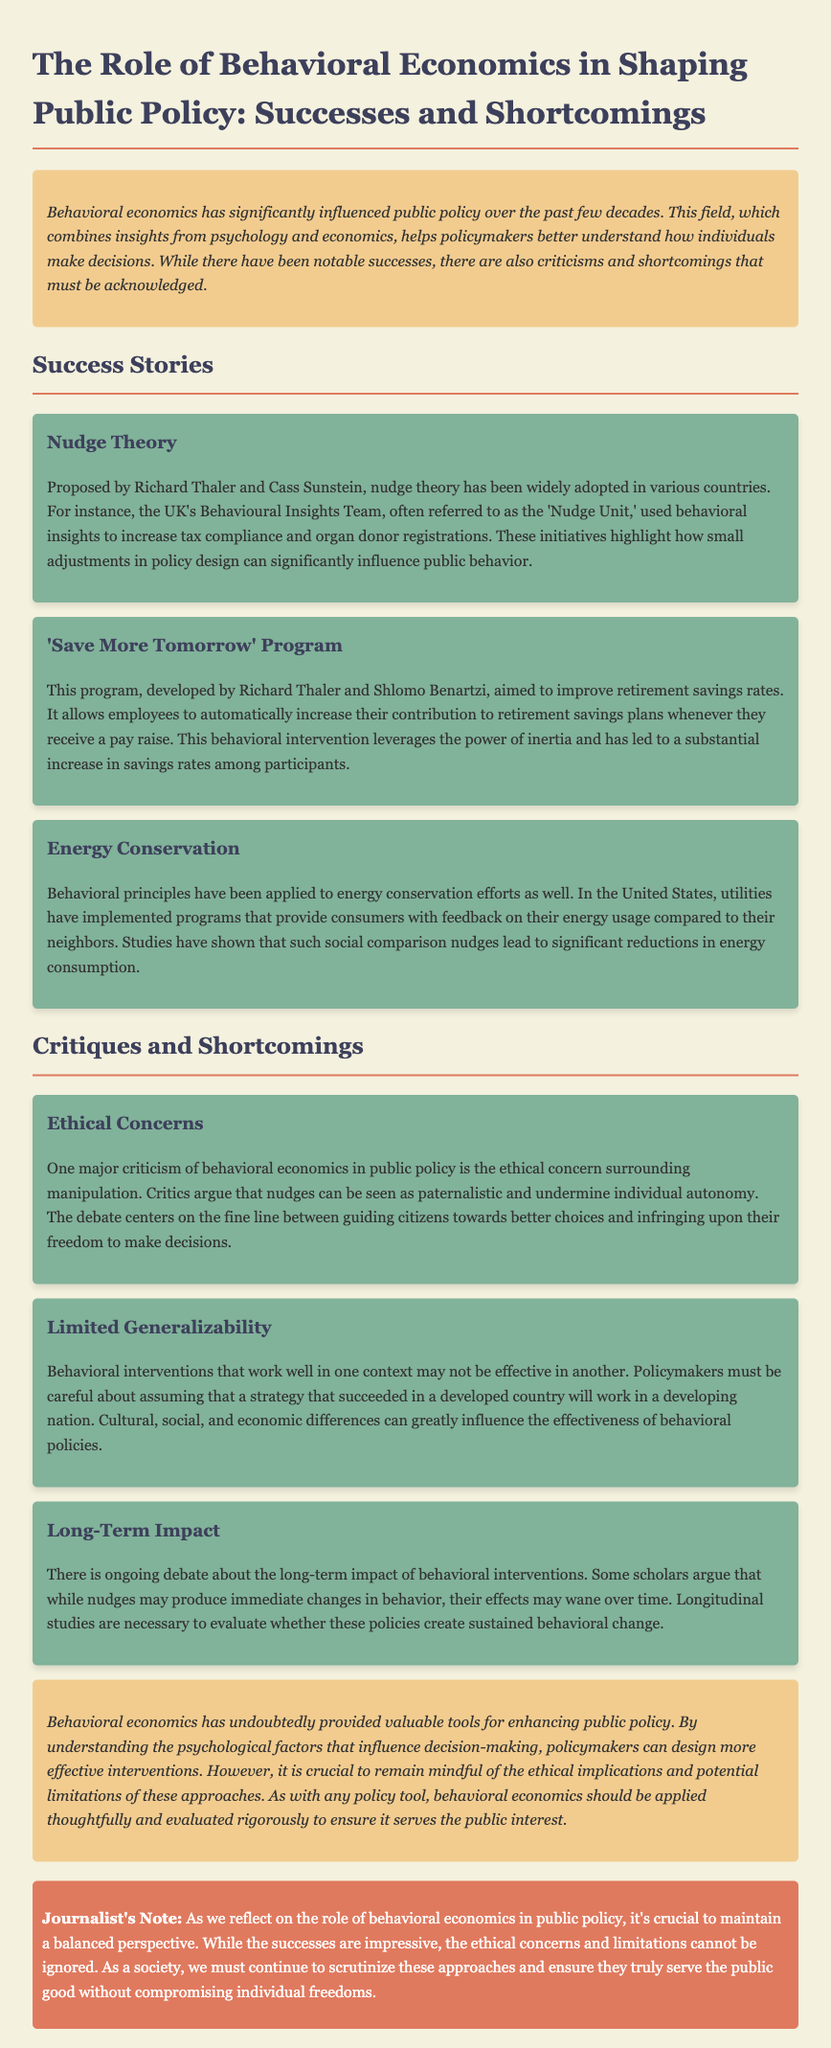What is the title of the document? The title is indicated in the heading of the document, summarizing its main theme.
Answer: The Role of Behavioral Economics in Shaping Public Policy: Successes and Shortcomings Who proposed the 'Save More Tomorrow' program? The program is attributed to two economists whose names are mentioned in relation to the initiative.
Answer: Richard Thaler and Shlomo Benartzi What did the UK's 'Nudge Unit' aim to increase? The document discusses specific aims of the initiatives taken by the 'Nudge Unit' in the UK.
Answer: Tax compliance and organ donor registrations What ethical concern is associated with behavioral economics? The document notes a particular issue regarding the nature of nudges and individual agency.
Answer: Paternalism What type of studies are necessary to evaluate the long-term impact of behavioral interventions? The document specifies a methodological approach needed for understanding sustained changes brought by these policies.
Answer: Longitudinal studies How many successes of behavioral economics are mentioned in the document? The document lists distinct examples of successful applications, which can be counted.
Answer: Three What is a potential limitation mentioned regarding the effectiveness of behavioral policies? The concerns highlighted relate to the applicability of interventions across different cultural contexts.
Answer: Limited generalizability 